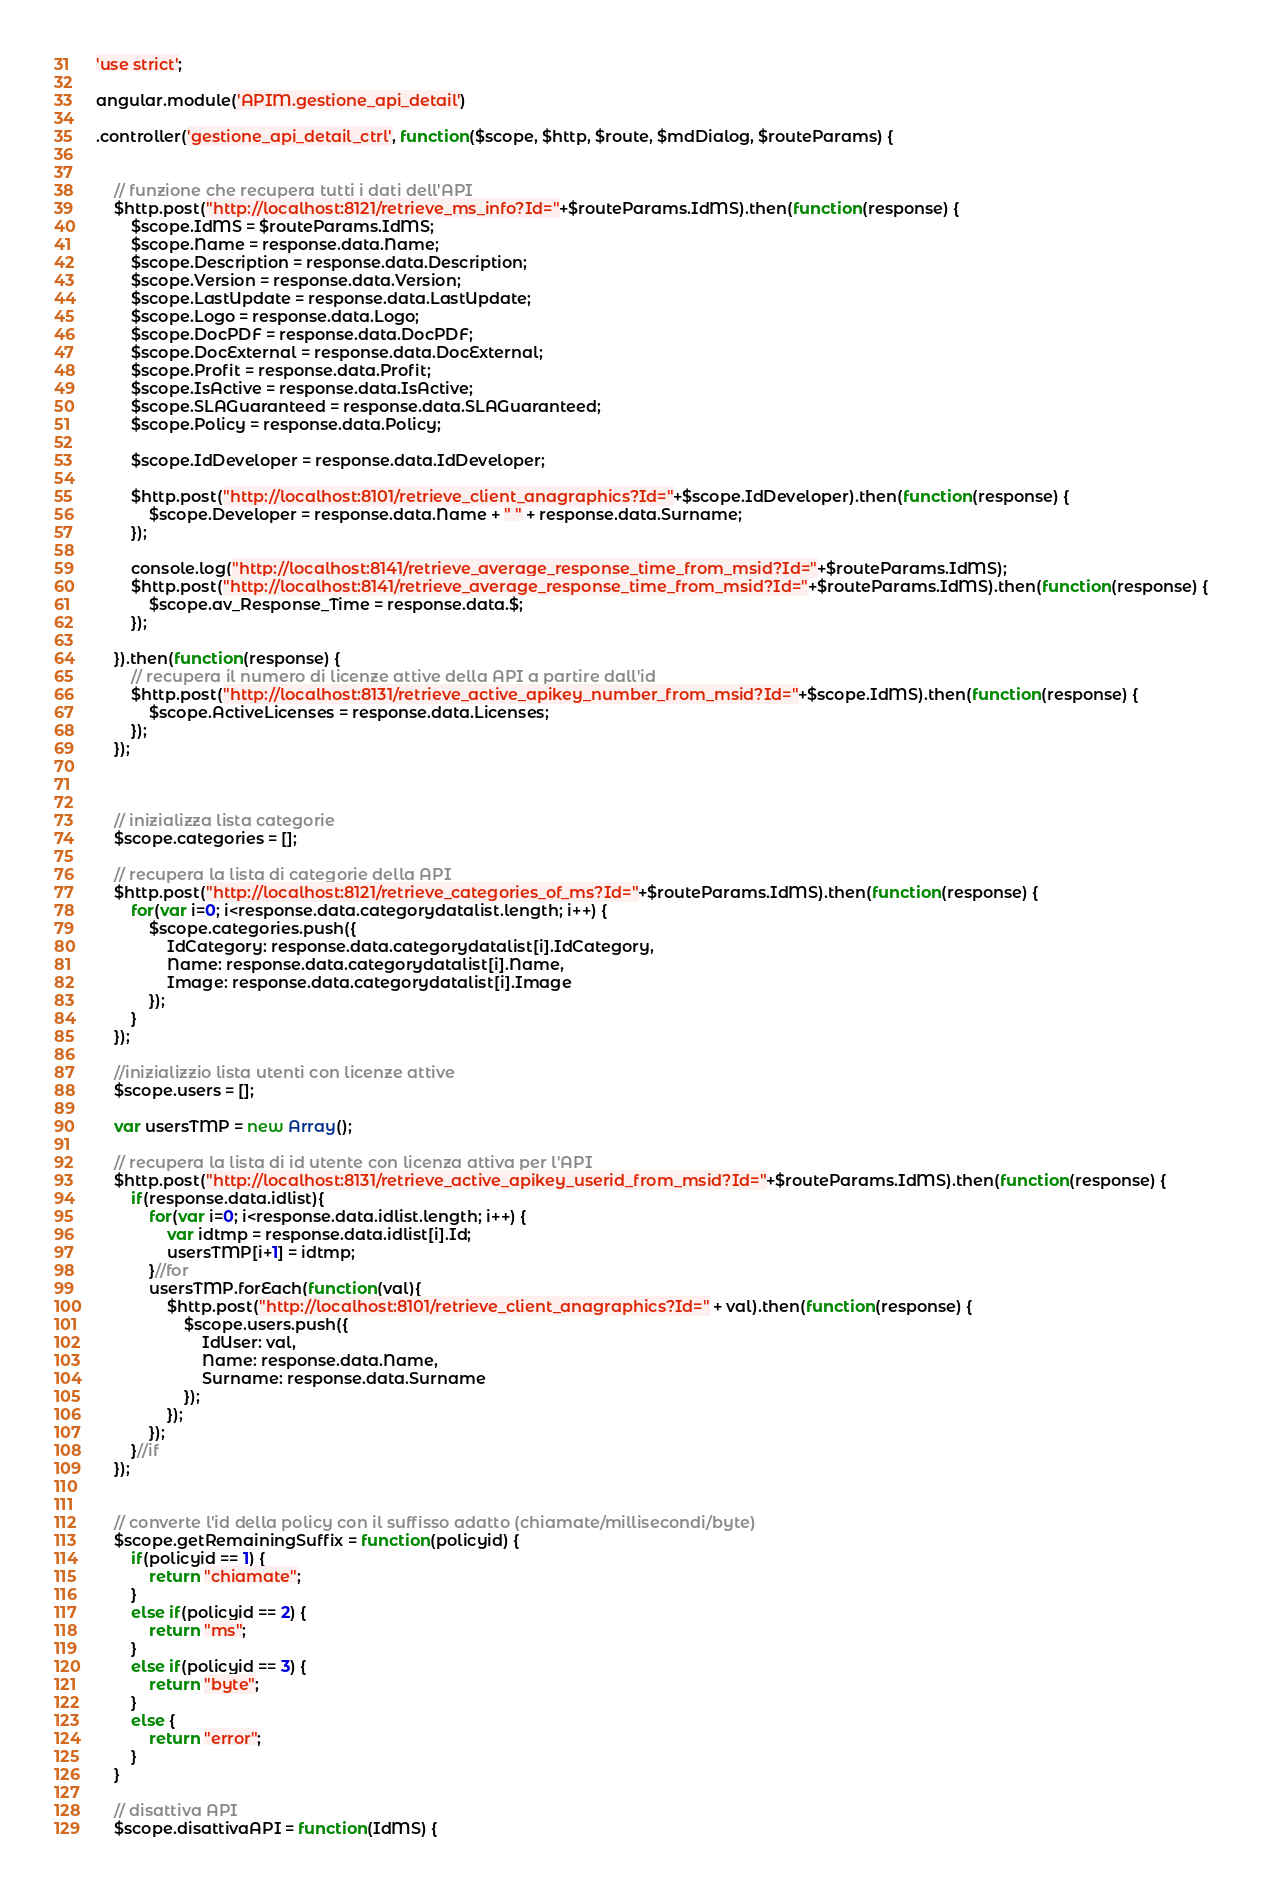Convert code to text. <code><loc_0><loc_0><loc_500><loc_500><_JavaScript_>'use strict';

angular.module('APIM.gestione_api_detail')

.controller('gestione_api_detail_ctrl', function($scope, $http, $route, $mdDialog, $routeParams) {


	// funzione che recupera tutti i dati dell'API
	$http.post("http://localhost:8121/retrieve_ms_info?Id="+$routeParams.IdMS).then(function(response) {
		$scope.IdMS = $routeParams.IdMS;
        $scope.Name = response.data.Name;
        $scope.Description = response.data.Description;
        $scope.Version = response.data.Version;
        $scope.LastUpdate = response.data.LastUpdate;
        $scope.Logo = response.data.Logo;
        $scope.DocPDF = response.data.DocPDF;
        $scope.DocExternal = response.data.DocExternal;
        $scope.Profit = response.data.Profit;
        $scope.IsActive = response.data.IsActive;
        $scope.SLAGuaranteed = response.data.SLAGuaranteed;
        $scope.Policy = response.data.Policy;
		
		$scope.IdDeveloper = response.data.IdDeveloper;

		$http.post("http://localhost:8101/retrieve_client_anagraphics?Id="+$scope.IdDeveloper).then(function(response) {
			$scope.Developer = response.data.Name + " " + response.data.Surname;
		});

		console.log("http://localhost:8141/retrieve_average_response_time_from_msid?Id="+$routeParams.IdMS);
		$http.post("http://localhost:8141/retrieve_average_response_time_from_msid?Id="+$routeParams.IdMS).then(function(response) {
			$scope.av_Response_Time = response.data.$;
		});

    }).then(function(response) {
		// recupera il numero di licenze attive della API a partire dall'id
		$http.post("http://localhost:8131/retrieve_active_apikey_number_from_msid?Id="+$scope.IdMS).then(function(response) {
			$scope.ActiveLicenses = response.data.Licenses;
		});
	});

	
	
	// inizializza lista categorie
	$scope.categories = [];
	
	// recupera la lista di categorie della API
	$http.post("http://localhost:8121/retrieve_categories_of_ms?Id="+$routeParams.IdMS).then(function(response) {
		for(var i=0; i<response.data.categorydatalist.length; i++) {
			$scope.categories.push({
				IdCategory: response.data.categorydatalist[i].IdCategory,
				Name: response.data.categorydatalist[i].Name,
				Image: response.data.categorydatalist[i].Image
			});
		}
	});

	//inizializzio lista utenti con licenze attive
	$scope.users = [];

	var usersTMP = new Array(); 

	// recupera la lista di id utente con licenza attiva per l'API
	$http.post("http://localhost:8131/retrieve_active_apikey_userid_from_msid?Id="+$routeParams.IdMS).then(function(response) {
		if(response.data.idlist){
			for(var i=0; i<response.data.idlist.length; i++) {
				var idtmp = response.data.idlist[i].Id;
				usersTMP[i+1] = idtmp;
			}//for
			usersTMP.forEach(function(val){
				$http.post("http://localhost:8101/retrieve_client_anagraphics?Id=" + val).then(function(response) {
					$scope.users.push({
						IdUser: val,
						Name: response.data.Name,
						Surname: response.data.Surname
					});
				});
			});
		}//if
	});


	// converte l'id della policy con il suffisso adatto (chiamate/millisecondi/byte)
	$scope.getRemainingSuffix = function(policyid) {
		if(policyid == 1) {
			return "chiamate";
		}
		else if(policyid == 2) {
			return "ms";
		}
		else if(policyid == 3) {
			return "byte";
		}
		else {
			return "error";
		}
	}

	// disattiva API
	$scope.disattivaAPI = function(IdMS) {</code> 